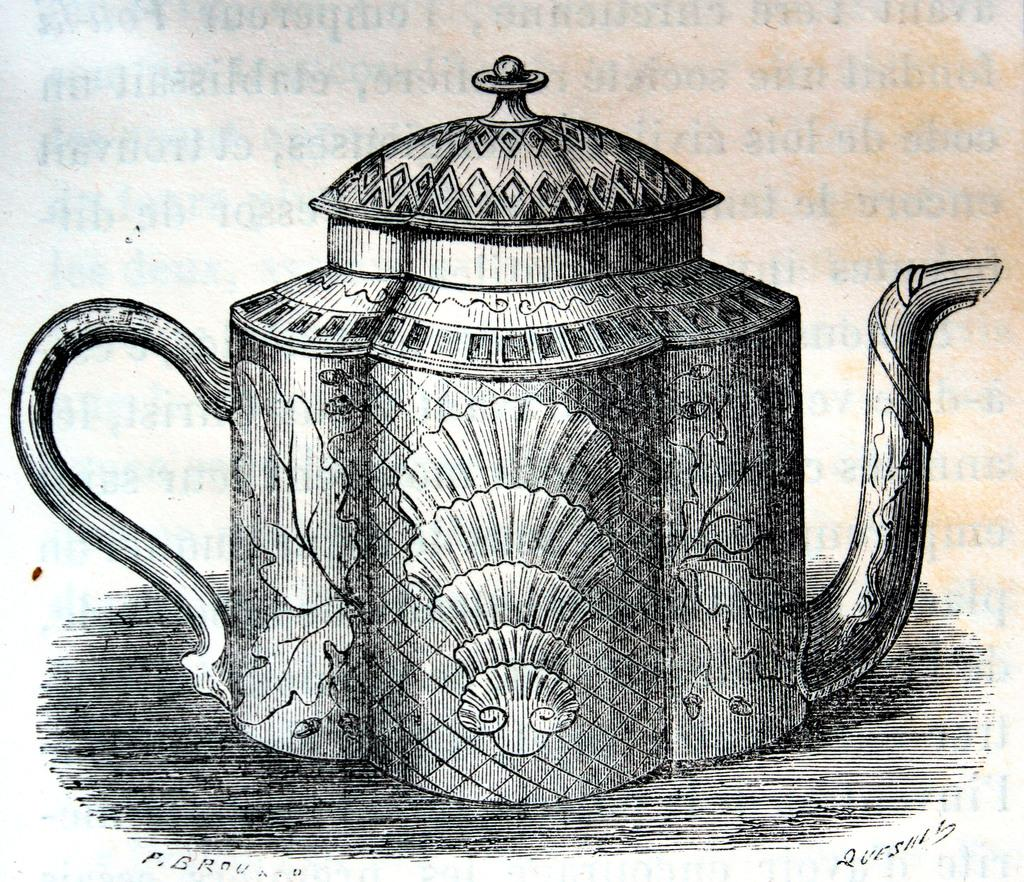What type of material is the main subject of the image made of? The main subject of the image is made of paper from a book. What is depicted on the paper in the image? There is a teapot drawing on the paper. Can you see a river flowing in the background of the teapot drawing? There is no river present in the image, as the image only features a drawing of a teapot on a piece of paper. 